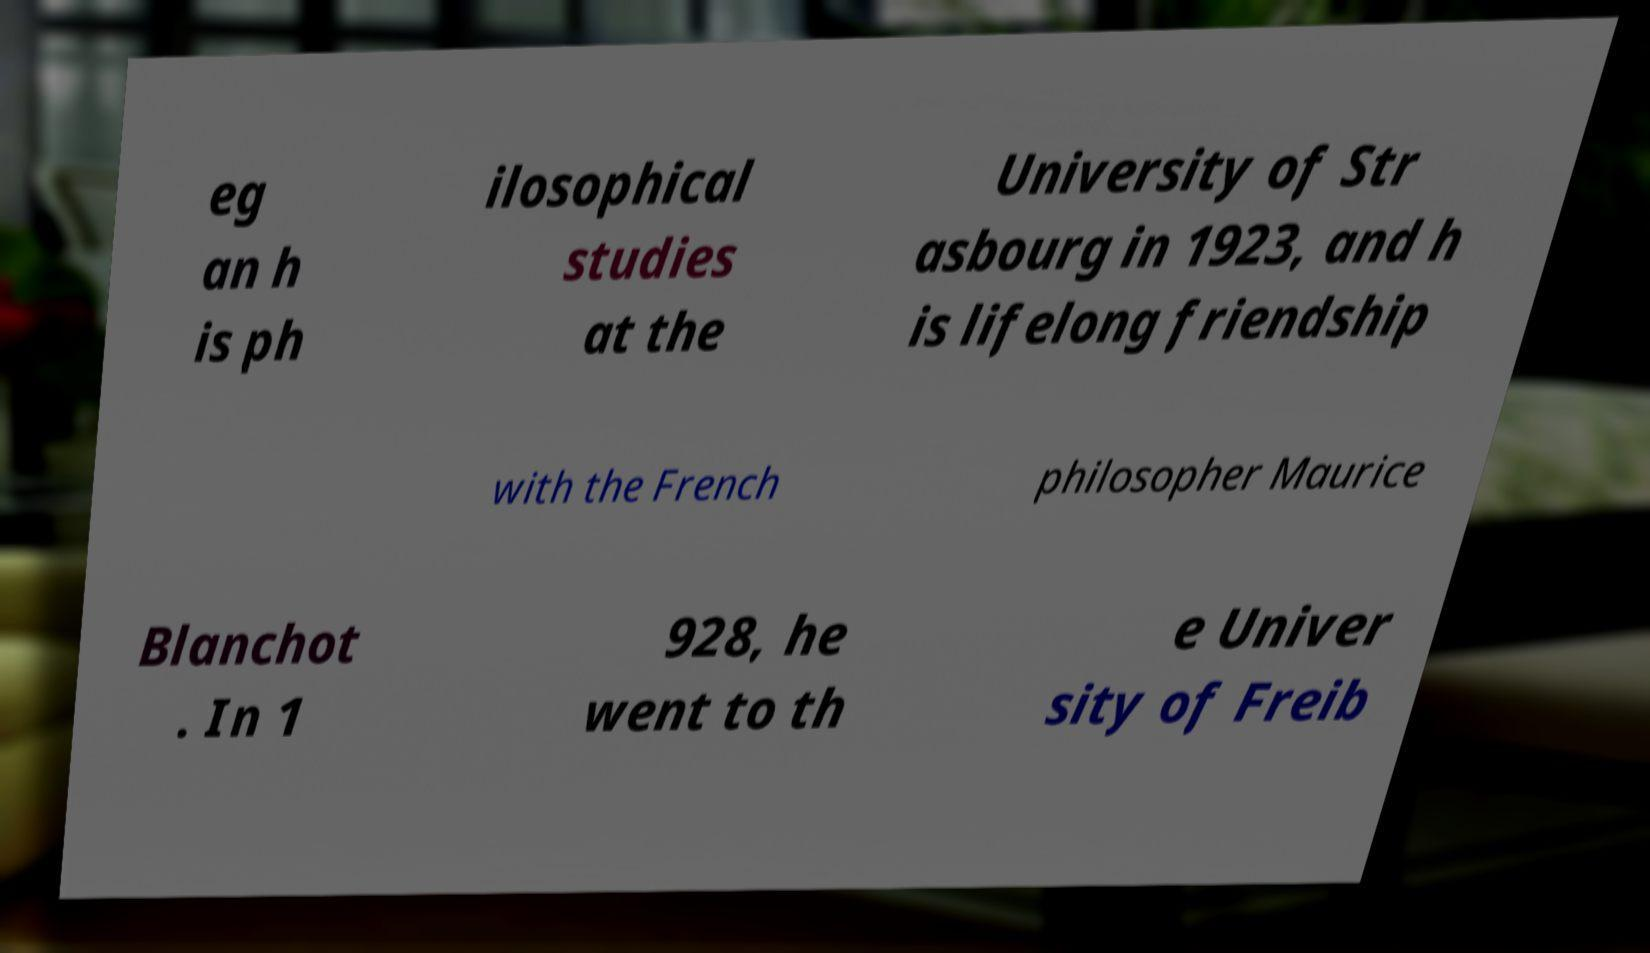I need the written content from this picture converted into text. Can you do that? eg an h is ph ilosophical studies at the University of Str asbourg in 1923, and h is lifelong friendship with the French philosopher Maurice Blanchot . In 1 928, he went to th e Univer sity of Freib 